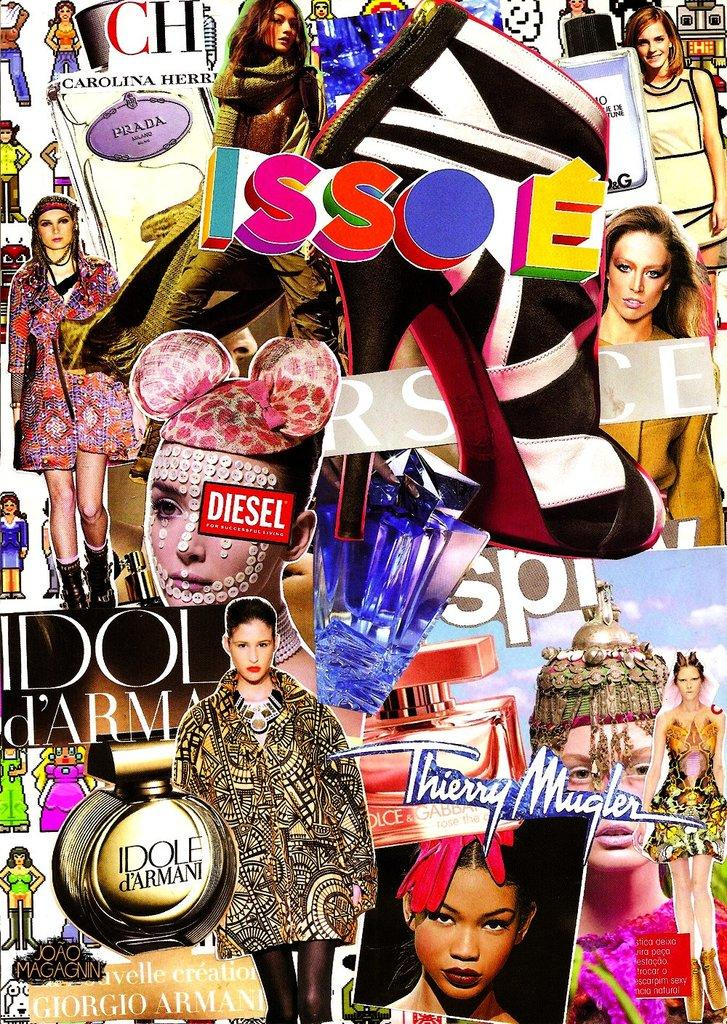Provide a one-sentence caption for the provided image. A montage of fashion models is messily splashed across the cover of Issoe magazine. 